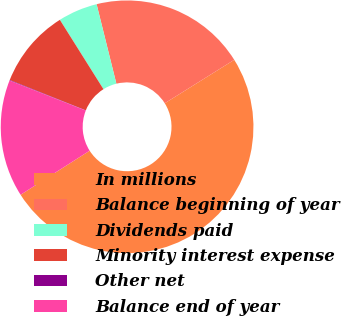<chart> <loc_0><loc_0><loc_500><loc_500><pie_chart><fcel>In millions<fcel>Balance beginning of year<fcel>Dividends paid<fcel>Minority interest expense<fcel>Other net<fcel>Balance end of year<nl><fcel>49.85%<fcel>19.99%<fcel>5.05%<fcel>10.03%<fcel>0.07%<fcel>15.01%<nl></chart> 